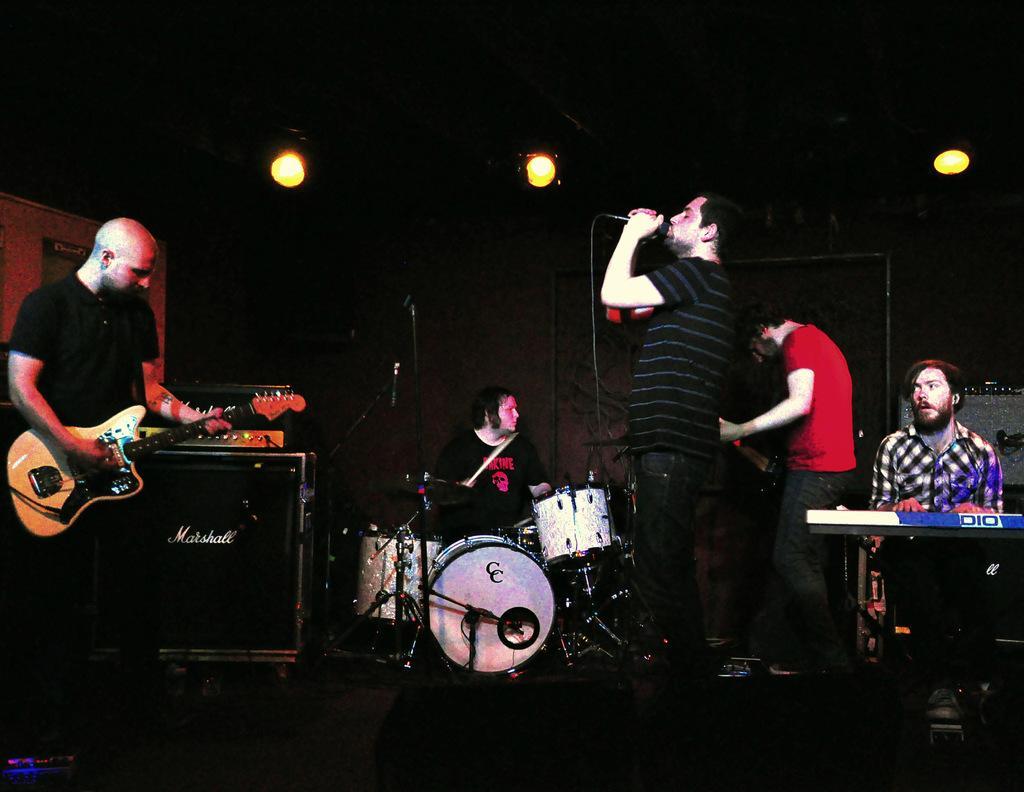How would you summarize this image in a sentence or two? There is a group of people. They are playing a musical instruments. 